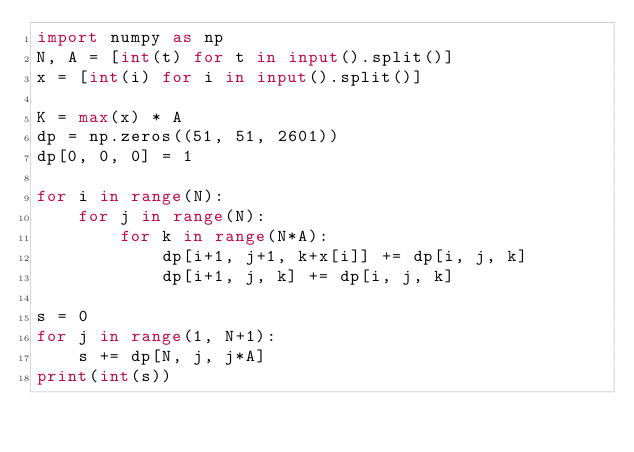Convert code to text. <code><loc_0><loc_0><loc_500><loc_500><_Python_>import numpy as np
N, A = [int(t) for t in input().split()]
x = [int(i) for i in input().split()]

K = max(x) * A
dp = np.zeros((51, 51, 2601))
dp[0, 0, 0] = 1

for i in range(N):
    for j in range(N):
        for k in range(N*A):
            dp[i+1, j+1, k+x[i]] += dp[i, j, k]
            dp[i+1, j, k] += dp[i, j, k]

s = 0
for j in range(1, N+1):
    s += dp[N, j, j*A]
print(int(s))</code> 